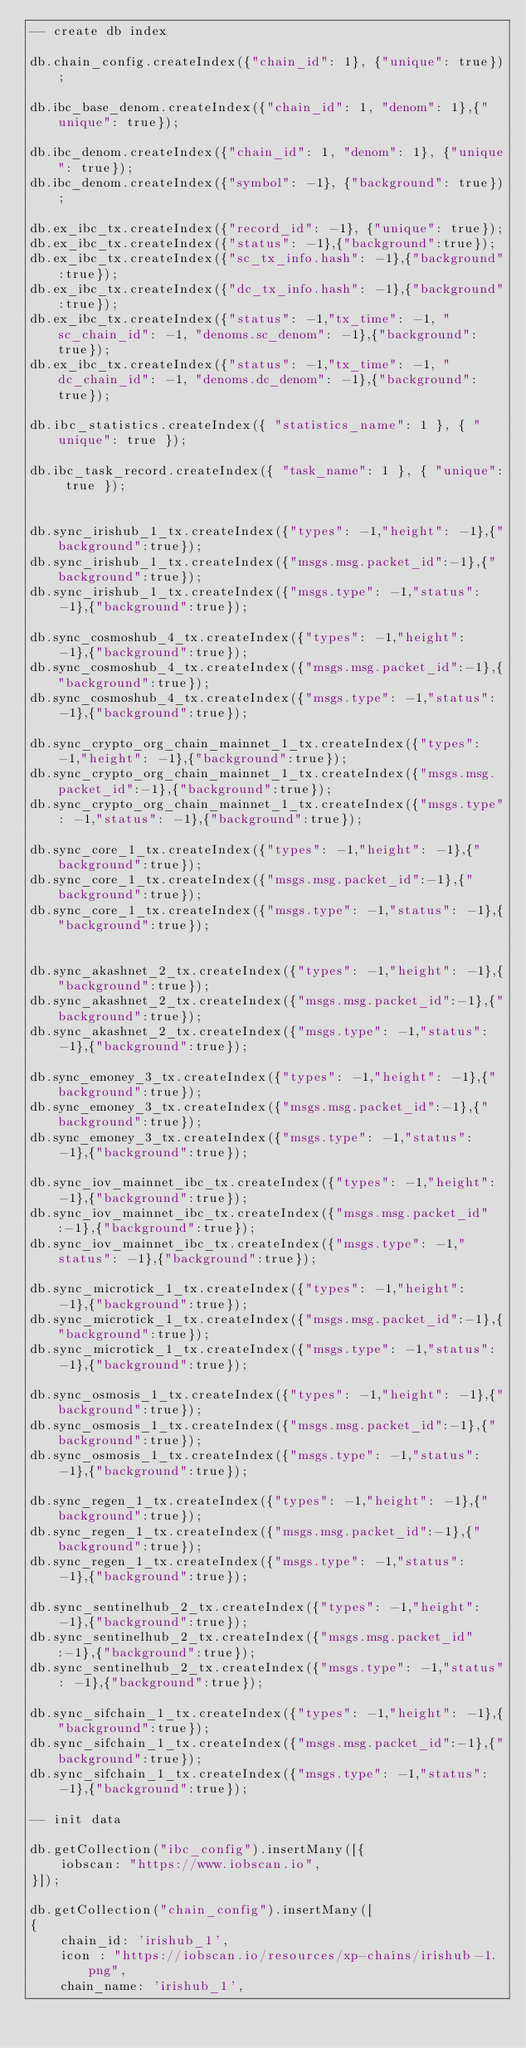<code> <loc_0><loc_0><loc_500><loc_500><_SQL_>-- create db index

db.chain_config.createIndex({"chain_id": 1}, {"unique": true});

db.ibc_base_denom.createIndex({"chain_id": 1, "denom": 1},{"unique": true});

db.ibc_denom.createIndex({"chain_id": 1, "denom": 1}, {"unique": true});
db.ibc_denom.createIndex({"symbol": -1}, {"background": true});

db.ex_ibc_tx.createIndex({"record_id": -1}, {"unique": true});
db.ex_ibc_tx.createIndex({"status": -1},{"background":true});
db.ex_ibc_tx.createIndex({"sc_tx_info.hash": -1},{"background":true});
db.ex_ibc_tx.createIndex({"dc_tx_info.hash": -1},{"background":true});
db.ex_ibc_tx.createIndex({"status": -1,"tx_time": -1, "sc_chain_id": -1, "denoms.sc_denom": -1},{"background":true});
db.ex_ibc_tx.createIndex({"status": -1,"tx_time": -1, "dc_chain_id": -1, "denoms.dc_denom": -1},{"background":true});

db.ibc_statistics.createIndex({ "statistics_name": 1 }, { "unique": true });

db.ibc_task_record.createIndex({ "task_name": 1 }, { "unique": true });


db.sync_irishub_1_tx.createIndex({"types": -1,"height": -1},{"background":true});
db.sync_irishub_1_tx.createIndex({"msgs.msg.packet_id":-1},{"background":true});
db.sync_irishub_1_tx.createIndex({"msgs.type": -1,"status": -1},{"background":true});

db.sync_cosmoshub_4_tx.createIndex({"types": -1,"height": -1},{"background":true});
db.sync_cosmoshub_4_tx.createIndex({"msgs.msg.packet_id":-1},{"background":true});
db.sync_cosmoshub_4_tx.createIndex({"msgs.type": -1,"status": -1},{"background":true});

db.sync_crypto_org_chain_mainnet_1_tx.createIndex({"types": -1,"height": -1},{"background":true});
db.sync_crypto_org_chain_mainnet_1_tx.createIndex({"msgs.msg.packet_id":-1},{"background":true});
db.sync_crypto_org_chain_mainnet_1_tx.createIndex({"msgs.type": -1,"status": -1},{"background":true});

db.sync_core_1_tx.createIndex({"types": -1,"height": -1},{"background":true});
db.sync_core_1_tx.createIndex({"msgs.msg.packet_id":-1},{"background":true});
db.sync_core_1_tx.createIndex({"msgs.type": -1,"status": -1},{"background":true});


db.sync_akashnet_2_tx.createIndex({"types": -1,"height": -1},{"background":true});
db.sync_akashnet_2_tx.createIndex({"msgs.msg.packet_id":-1},{"background":true});
db.sync_akashnet_2_tx.createIndex({"msgs.type": -1,"status": -1},{"background":true});

db.sync_emoney_3_tx.createIndex({"types": -1,"height": -1},{"background":true});
db.sync_emoney_3_tx.createIndex({"msgs.msg.packet_id":-1},{"background":true});
db.sync_emoney_3_tx.createIndex({"msgs.type": -1,"status": -1},{"background":true});

db.sync_iov_mainnet_ibc_tx.createIndex({"types": -1,"height": -1},{"background":true});
db.sync_iov_mainnet_ibc_tx.createIndex({"msgs.msg.packet_id":-1},{"background":true});
db.sync_iov_mainnet_ibc_tx.createIndex({"msgs.type": -1,"status": -1},{"background":true});

db.sync_microtick_1_tx.createIndex({"types": -1,"height": -1},{"background":true});
db.sync_microtick_1_tx.createIndex({"msgs.msg.packet_id":-1},{"background":true});
db.sync_microtick_1_tx.createIndex({"msgs.type": -1,"status": -1},{"background":true});

db.sync_osmosis_1_tx.createIndex({"types": -1,"height": -1},{"background":true});
db.sync_osmosis_1_tx.createIndex({"msgs.msg.packet_id":-1},{"background":true});
db.sync_osmosis_1_tx.createIndex({"msgs.type": -1,"status": -1},{"background":true});

db.sync_regen_1_tx.createIndex({"types": -1,"height": -1},{"background":true});
db.sync_regen_1_tx.createIndex({"msgs.msg.packet_id":-1},{"background":true});
db.sync_regen_1_tx.createIndex({"msgs.type": -1,"status": -1},{"background":true});

db.sync_sentinelhub_2_tx.createIndex({"types": -1,"height": -1},{"background":true});
db.sync_sentinelhub_2_tx.createIndex({"msgs.msg.packet_id":-1},{"background":true});
db.sync_sentinelhub_2_tx.createIndex({"msgs.type": -1,"status": -1},{"background":true});

db.sync_sifchain_1_tx.createIndex({"types": -1,"height": -1},{"background":true});
db.sync_sifchain_1_tx.createIndex({"msgs.msg.packet_id":-1},{"background":true});
db.sync_sifchain_1_tx.createIndex({"msgs.type": -1,"status": -1},{"background":true});

-- init data

db.getCollection("ibc_config").insertMany([{
    iobscan: "https://www.iobscan.io",
}]);

db.getCollection("chain_config").insertMany([
{
    chain_id: 'irishub_1',
    icon : "https://iobscan.io/resources/xp-chains/irishub-1.png",
    chain_name: 'irishub_1',</code> 